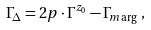Convert formula to latex. <formula><loc_0><loc_0><loc_500><loc_500>\Gamma _ { \Delta } & = 2 p \cdot \Gamma ^ { z _ { 0 } } - \Gamma _ { m \arg } \ ,</formula> 